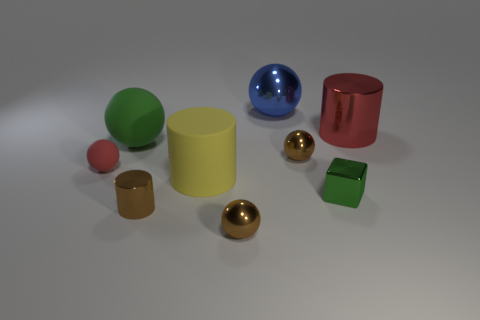Subtract all green balls. How many balls are left? 4 Subtract all tiny red balls. How many balls are left? 4 Subtract all gray spheres. Subtract all gray blocks. How many spheres are left? 5 Add 1 tiny rubber spheres. How many objects exist? 10 Subtract all cylinders. How many objects are left? 6 Add 1 tiny cylinders. How many tiny cylinders exist? 2 Subtract 0 cyan balls. How many objects are left? 9 Subtract all tiny metallic blocks. Subtract all small brown cylinders. How many objects are left? 7 Add 7 large green matte spheres. How many large green matte spheres are left? 8 